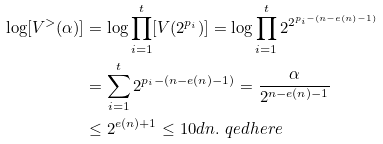<formula> <loc_0><loc_0><loc_500><loc_500>\log [ V ^ { > } ( \alpha ) ] & = \log \prod _ { i = 1 } ^ { t } [ V ( 2 ^ { p _ { i } } ) ] = \log \prod _ { i = 1 } ^ { t } 2 ^ { 2 ^ { p _ { i } - ( n - e ( n ) - 1 ) } } \\ & = \sum _ { i = 1 } ^ { t } 2 ^ { p _ { i } - ( n - e ( n ) - 1 ) } = \frac { \alpha } { 2 ^ { n - e ( n ) - 1 } } \\ & \leq 2 ^ { e ( n ) + 1 } \leq 1 0 d n . \ q e d h e r e</formula> 